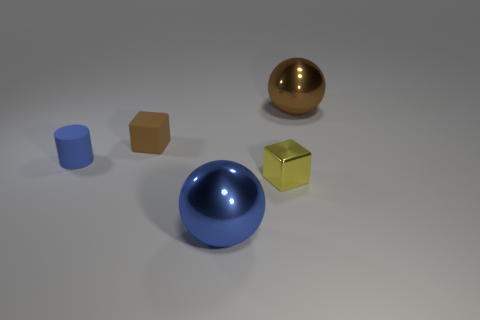Add 1 blue cylinders. How many objects exist? 6 Subtract all cylinders. How many objects are left? 4 Add 4 yellow metal things. How many yellow metal things are left? 5 Add 3 tiny matte blocks. How many tiny matte blocks exist? 4 Subtract 0 red cylinders. How many objects are left? 5 Subtract all large brown balls. Subtract all big purple objects. How many objects are left? 4 